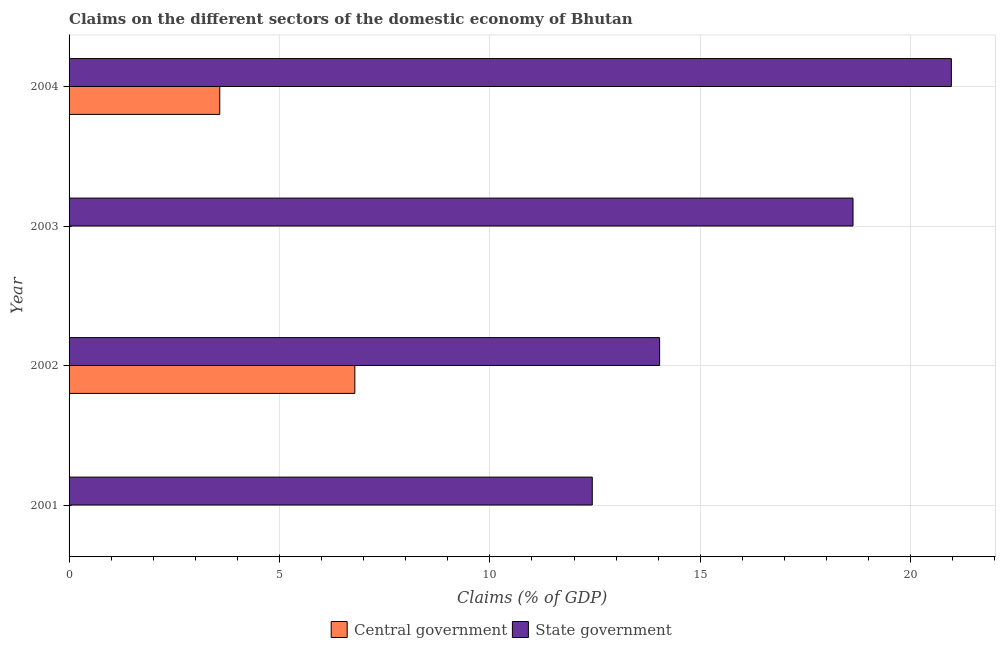Are the number of bars per tick equal to the number of legend labels?
Offer a very short reply. No. Are the number of bars on each tick of the Y-axis equal?
Your response must be concise. No. How many bars are there on the 1st tick from the top?
Ensure brevity in your answer.  2. What is the label of the 4th group of bars from the top?
Your response must be concise. 2001. In how many cases, is the number of bars for a given year not equal to the number of legend labels?
Provide a short and direct response. 2. What is the claims on central government in 2003?
Give a very brief answer. 0. Across all years, what is the maximum claims on state government?
Ensure brevity in your answer.  20.97. Across all years, what is the minimum claims on state government?
Ensure brevity in your answer.  12.43. In which year was the claims on central government maximum?
Ensure brevity in your answer.  2002. What is the total claims on central government in the graph?
Make the answer very short. 10.37. What is the difference between the claims on state government in 2002 and that in 2004?
Your response must be concise. -6.93. What is the difference between the claims on state government in 2002 and the claims on central government in 2003?
Provide a short and direct response. 14.03. What is the average claims on central government per year?
Keep it short and to the point. 2.59. In the year 2004, what is the difference between the claims on central government and claims on state government?
Your answer should be very brief. -17.39. In how many years, is the claims on central government greater than 9 %?
Provide a short and direct response. 0. What is the ratio of the claims on state government in 2002 to that in 2004?
Offer a very short reply. 0.67. What is the difference between the highest and the second highest claims on state government?
Your answer should be compact. 2.34. What is the difference between the highest and the lowest claims on central government?
Your answer should be very brief. 6.79. In how many years, is the claims on central government greater than the average claims on central government taken over all years?
Ensure brevity in your answer.  2. How many years are there in the graph?
Provide a succinct answer. 4. What is the difference between two consecutive major ticks on the X-axis?
Make the answer very short. 5. Where does the legend appear in the graph?
Your answer should be very brief. Bottom center. How many legend labels are there?
Give a very brief answer. 2. How are the legend labels stacked?
Your response must be concise. Horizontal. What is the title of the graph?
Make the answer very short. Claims on the different sectors of the domestic economy of Bhutan. What is the label or title of the X-axis?
Your answer should be compact. Claims (% of GDP). What is the Claims (% of GDP) of Central government in 2001?
Your answer should be compact. 0. What is the Claims (% of GDP) in State government in 2001?
Your answer should be very brief. 12.43. What is the Claims (% of GDP) of Central government in 2002?
Keep it short and to the point. 6.79. What is the Claims (% of GDP) of State government in 2002?
Provide a short and direct response. 14.03. What is the Claims (% of GDP) in Central government in 2003?
Provide a succinct answer. 0. What is the Claims (% of GDP) in State government in 2003?
Your answer should be very brief. 18.63. What is the Claims (% of GDP) of Central government in 2004?
Give a very brief answer. 3.58. What is the Claims (% of GDP) in State government in 2004?
Your response must be concise. 20.97. Across all years, what is the maximum Claims (% of GDP) of Central government?
Keep it short and to the point. 6.79. Across all years, what is the maximum Claims (% of GDP) in State government?
Your answer should be compact. 20.97. Across all years, what is the minimum Claims (% of GDP) in State government?
Make the answer very short. 12.43. What is the total Claims (% of GDP) in Central government in the graph?
Your response must be concise. 10.37. What is the total Claims (% of GDP) of State government in the graph?
Make the answer very short. 66.07. What is the difference between the Claims (% of GDP) in State government in 2001 and that in 2002?
Provide a short and direct response. -1.6. What is the difference between the Claims (% of GDP) of State government in 2001 and that in 2003?
Offer a terse response. -6.2. What is the difference between the Claims (% of GDP) in State government in 2001 and that in 2004?
Your answer should be compact. -8.53. What is the difference between the Claims (% of GDP) in State government in 2002 and that in 2003?
Your response must be concise. -4.6. What is the difference between the Claims (% of GDP) of Central government in 2002 and that in 2004?
Keep it short and to the point. 3.21. What is the difference between the Claims (% of GDP) in State government in 2002 and that in 2004?
Offer a terse response. -6.93. What is the difference between the Claims (% of GDP) in State government in 2003 and that in 2004?
Offer a very short reply. -2.34. What is the difference between the Claims (% of GDP) in Central government in 2002 and the Claims (% of GDP) in State government in 2003?
Provide a short and direct response. -11.84. What is the difference between the Claims (% of GDP) in Central government in 2002 and the Claims (% of GDP) in State government in 2004?
Your response must be concise. -14.18. What is the average Claims (% of GDP) in Central government per year?
Your answer should be very brief. 2.59. What is the average Claims (% of GDP) in State government per year?
Provide a succinct answer. 16.52. In the year 2002, what is the difference between the Claims (% of GDP) of Central government and Claims (% of GDP) of State government?
Make the answer very short. -7.24. In the year 2004, what is the difference between the Claims (% of GDP) of Central government and Claims (% of GDP) of State government?
Your answer should be compact. -17.39. What is the ratio of the Claims (% of GDP) of State government in 2001 to that in 2002?
Provide a succinct answer. 0.89. What is the ratio of the Claims (% of GDP) of State government in 2001 to that in 2003?
Provide a succinct answer. 0.67. What is the ratio of the Claims (% of GDP) of State government in 2001 to that in 2004?
Give a very brief answer. 0.59. What is the ratio of the Claims (% of GDP) in State government in 2002 to that in 2003?
Your answer should be compact. 0.75. What is the ratio of the Claims (% of GDP) in Central government in 2002 to that in 2004?
Provide a short and direct response. 1.9. What is the ratio of the Claims (% of GDP) in State government in 2002 to that in 2004?
Your answer should be compact. 0.67. What is the ratio of the Claims (% of GDP) of State government in 2003 to that in 2004?
Ensure brevity in your answer.  0.89. What is the difference between the highest and the second highest Claims (% of GDP) in State government?
Provide a short and direct response. 2.34. What is the difference between the highest and the lowest Claims (% of GDP) of Central government?
Keep it short and to the point. 6.79. What is the difference between the highest and the lowest Claims (% of GDP) in State government?
Make the answer very short. 8.53. 